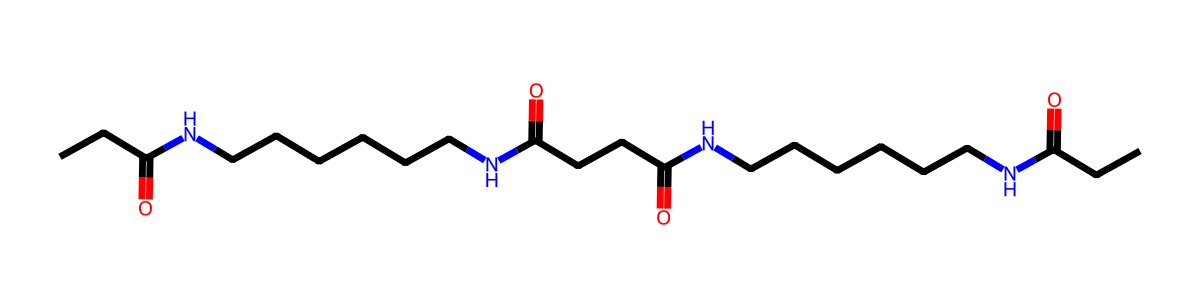what is the total number of carbon atoms in the structure? By analyzing the SMILES representation provided, we can count each carbon (C) atom. The structure shows a total of 18 carbon atoms connected in various forms.
Answer: 18 how many nitrogen atoms are present in the structure? Looking at the SMILES, each occurrence of the nitrogen atom (N) needs to be counted. There are 4 nitrogen atoms in the structure based on the notation.
Answer: 4 what type of functional groups are present in this structure? The functional groups can be determined from the SMILES. The presence of C(=O) indicates carbonyl groups (amide functionality), and the nitrogen atoms suggest it features amide functional groups as well.
Answer: amide how many carbonyl groups are present in the entire molecule? By reviewing the structure, we find that there are two C(=O) groups located in different segments of the molecule, confirming the presence of two carbonyls.
Answer: 2 what type of polymer does this structure represent? The structure's repetition of amide linkages indicates that it is a type of polyamide, which is consistent with nylon fibers. This is further confirmed by the repeating motif that characterizes polyamides.
Answer: polyamide which part of the structure is responsible for flexibility? Analyzing the long carbon chains (the aliphatic segments), we can see that they contribute to the flexibility of the material due to their flexible nature, which allows for bending and twisting in fibers.
Answer: carbon chains what kind of materials might this polymer be used to protect? Given that nylon is commonly used in durable and flexible applications, particularly in camera equipment carrying cases, this polymer structure would be effective in protecting delicate items against impacts and abrasions.
Answer: camera equipment 